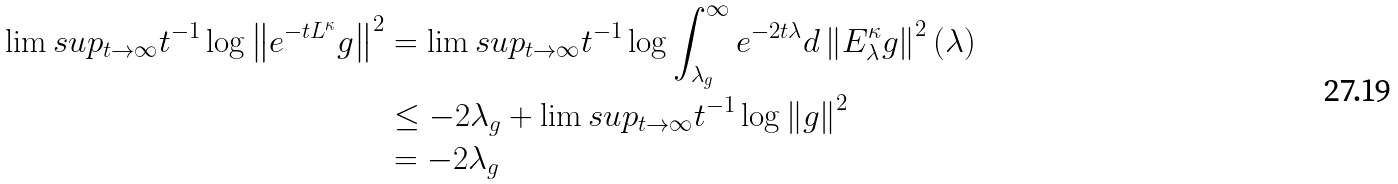Convert formula to latex. <formula><loc_0><loc_0><loc_500><loc_500>\lim s u p _ { t \to \infty } t ^ { - 1 } \log \left \| e ^ { - t L ^ { \kappa } } g \right \| ^ { 2 } & = \lim s u p _ { t \to \infty } t ^ { - 1 } \log \int _ { \lambda _ { g } } ^ { \infty } e ^ { - 2 t \lambda } d \left \| E ^ { \kappa } _ { \lambda } g \right \| ^ { 2 } ( \lambda ) \\ & \leq - 2 \lambda _ { g } + \lim s u p _ { t \to \infty } t ^ { - 1 } \log \left \| g \right \| ^ { 2 } \\ & = - 2 \lambda _ { g }</formula> 